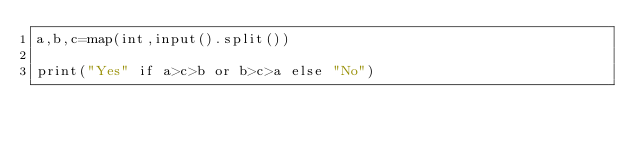<code> <loc_0><loc_0><loc_500><loc_500><_Python_>a,b,c=map(int,input().split())

print("Yes" if a>c>b or b>c>a else "No")</code> 